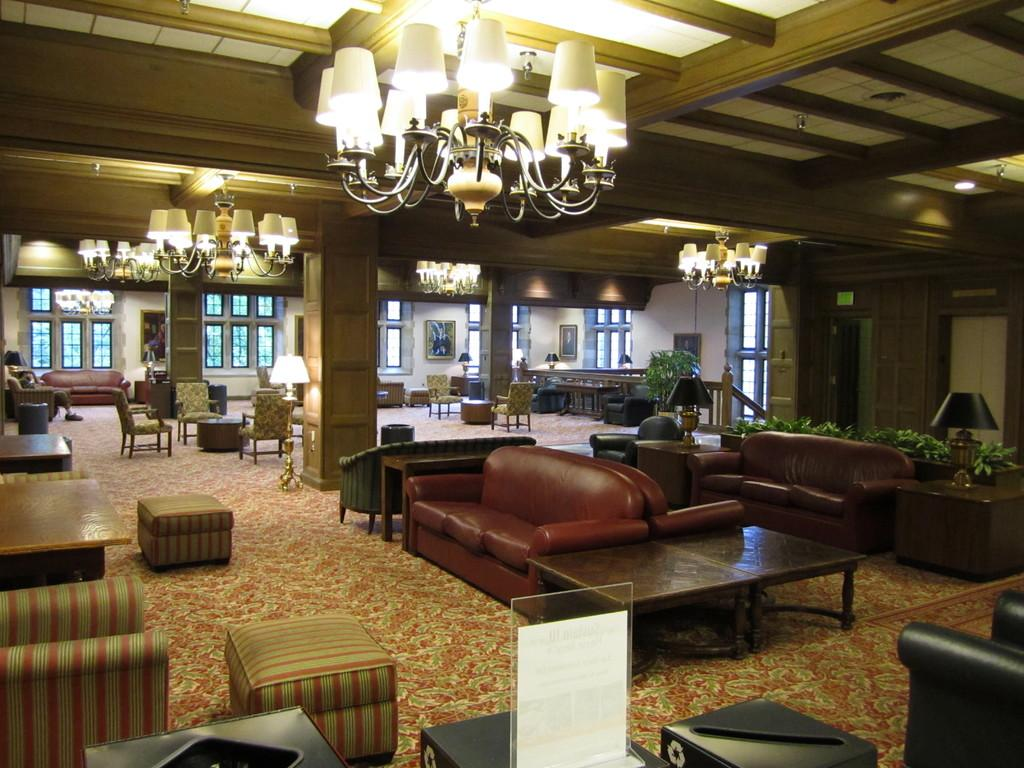Where was the image taken? The image is taken inside a building. What type of furniture can be seen in the image? There are many sofas and chairs in the image. What can be seen in the background of the image? There are windows and a wall in the background of the image. Can you describe the lighting in the image? There is a light hanging at the top of the image. What is the plot of the story unfolding in the image? There is no story or plot depicted in the image; it is a still photograph of a room with furniture. What type of sound can be heard coming from the image? There is no sound present in the image, as it is a still photograph. 